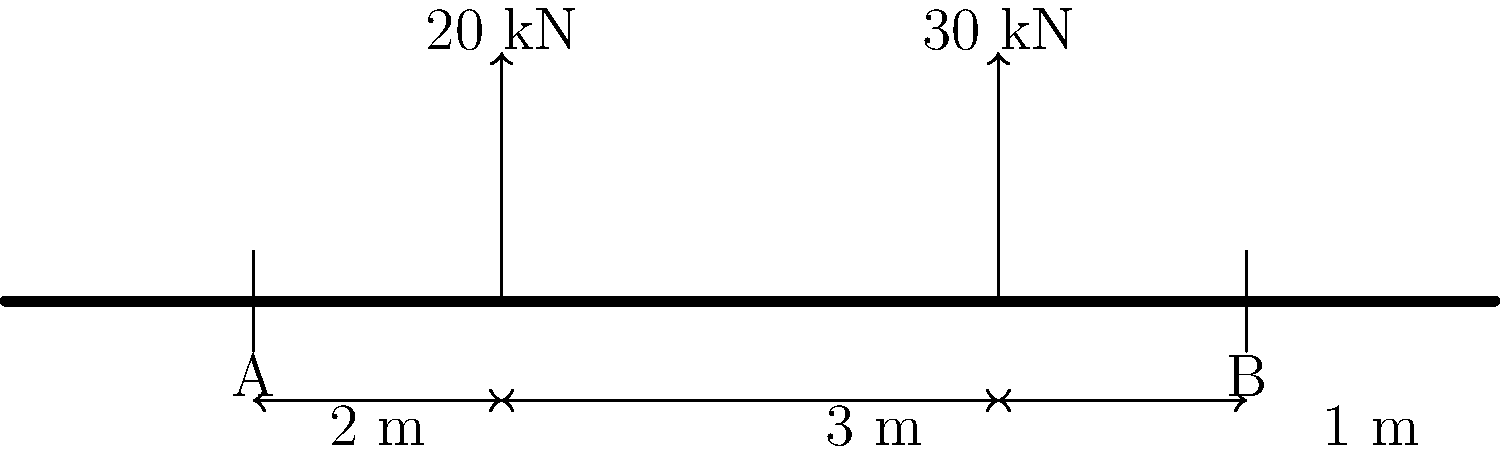In your long career covering the Philadelphia Flyers, you've seen many arenas built. Now, let's consider a simple beam bridge similar to those used in arena construction. A beam of length 6 m is supported at points A and B, 5 m apart. Two point loads are applied: 20 kN at 2 m from A, and 30 kN at 5 m from A. What is the reaction force at support A? Let's approach this step-by-step:

1) First, we need to set up the equilibrium equations. For a beam in equilibrium, the sum of all forces and moments must be zero.

2) Let's denote the reaction forces at A and B as $R_A$ and $R_B$ respectively.

3) Sum of vertical forces:
   $$R_A + R_B - 20 - 30 = 0$$

4) Taking moments about point A:
   $$(20 \times 2) + (30 \times 5) - (R_B \times 5) = 0$$

5) Simplify the moment equation:
   $$40 + 150 - 5R_B = 0$$
   $$190 - 5R_B = 0$$
   $$5R_B = 190$$
   $$R_B = 38 \text{ kN}$$

6) Now we can substitute this value back into the force equation:
   $$R_A + 38 - 20 - 30 = 0$$
   $$R_A = 20 + 30 - 38 = 12 \text{ kN}$$

Therefore, the reaction force at support A is 12 kN.
Answer: 12 kN 